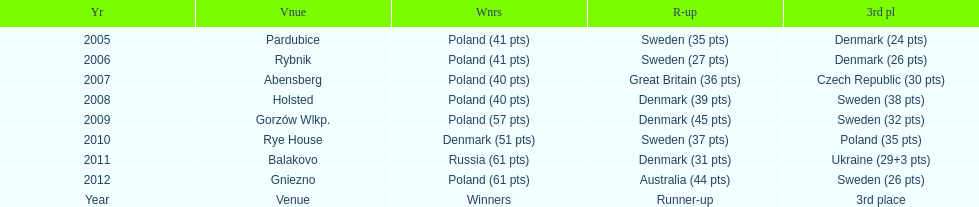Which team has the most third place wins in the speedway junior world championship between 2005 and 2012? Sweden. 